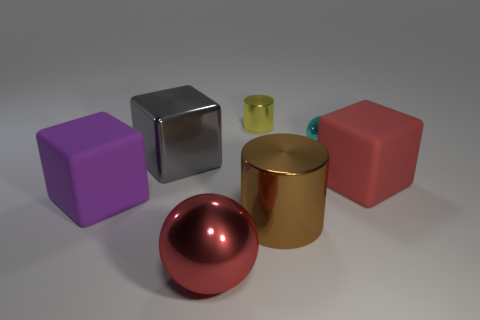Add 2 small blue matte spheres. How many objects exist? 9 Subtract all spheres. How many objects are left? 5 Subtract all tiny spheres. Subtract all red rubber objects. How many objects are left? 5 Add 1 small cyan balls. How many small cyan balls are left? 2 Add 7 red spheres. How many red spheres exist? 8 Subtract 0 red cylinders. How many objects are left? 7 